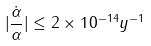Convert formula to latex. <formula><loc_0><loc_0><loc_500><loc_500>| \frac { \dot { \alpha } } { \alpha } | \leq 2 \times 1 0 ^ { - 1 4 } y ^ { - 1 } \,</formula> 